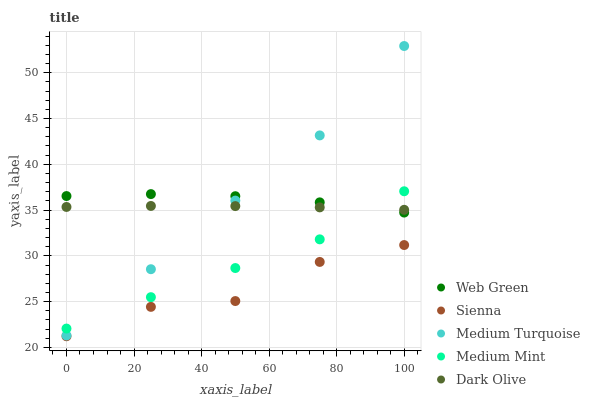Does Sienna have the minimum area under the curve?
Answer yes or no. Yes. Does Medium Turquoise have the maximum area under the curve?
Answer yes or no. Yes. Does Medium Mint have the minimum area under the curve?
Answer yes or no. No. Does Medium Mint have the maximum area under the curve?
Answer yes or no. No. Is Dark Olive the smoothest?
Answer yes or no. Yes. Is Sienna the roughest?
Answer yes or no. Yes. Is Medium Mint the smoothest?
Answer yes or no. No. Is Medium Mint the roughest?
Answer yes or no. No. Does Sienna have the lowest value?
Answer yes or no. Yes. Does Medium Mint have the lowest value?
Answer yes or no. No. Does Medium Turquoise have the highest value?
Answer yes or no. Yes. Does Medium Mint have the highest value?
Answer yes or no. No. Is Sienna less than Medium Mint?
Answer yes or no. Yes. Is Medium Mint greater than Sienna?
Answer yes or no. Yes. Does Dark Olive intersect Web Green?
Answer yes or no. Yes. Is Dark Olive less than Web Green?
Answer yes or no. No. Is Dark Olive greater than Web Green?
Answer yes or no. No. Does Sienna intersect Medium Mint?
Answer yes or no. No. 